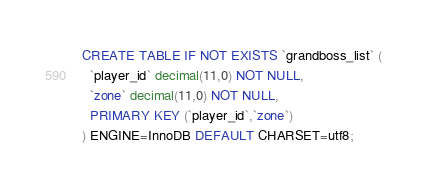Convert code to text. <code><loc_0><loc_0><loc_500><loc_500><_SQL_>CREATE TABLE IF NOT EXISTS `grandboss_list` (
  `player_id` decimal(11,0) NOT NULL,
  `zone` decimal(11,0) NOT NULL,
  PRIMARY KEY (`player_id`,`zone`)
) ENGINE=InnoDB DEFAULT CHARSET=utf8;</code> 